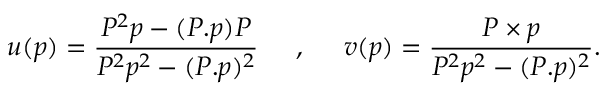<formula> <loc_0><loc_0><loc_500><loc_500>u ( p ) = \frac { P ^ { 2 } p - ( P . p ) P } { P ^ { 2 } p ^ { 2 } - ( P . p ) ^ { 2 } } \, , \, v ( p ) = \frac { P \times p } { P ^ { 2 } p ^ { 2 } - ( P . p ) ^ { 2 } } .</formula> 